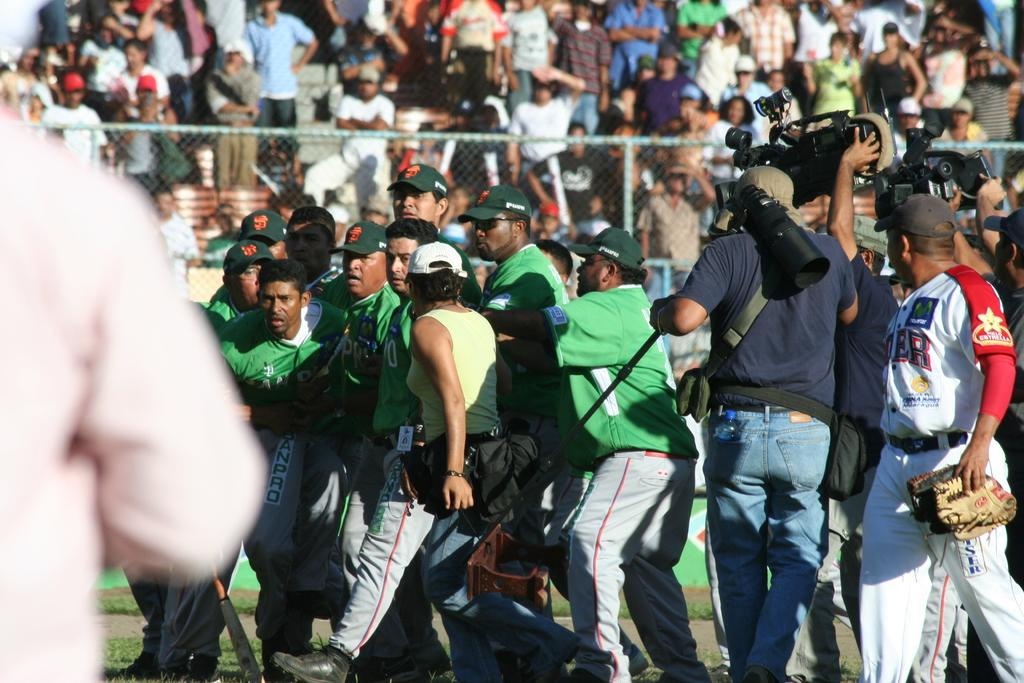What are the people in the image doing? There are people walking in the image. What might the people with cameras be doing? Some people are holding cameras, which suggests they might be taking pictures or recording. What is the brown object being held by some people? There is an object in brown color being held by some people, but the specific object is not clear from the image. What can be seen in the background of the image? There is net fencing visible in the background, and a group of people are standing in the background. What type of quartz can be seen being smashed by the people in the image? There is no quartz or smashing activity visible in the image. How many bricks are being carried by the people in the image? There is no indication of bricks being carried by the people in the image. 